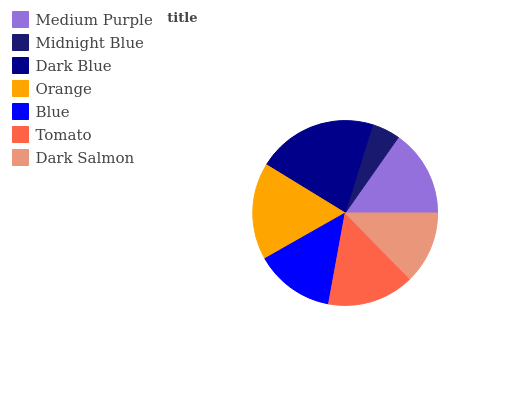Is Midnight Blue the minimum?
Answer yes or no. Yes. Is Dark Blue the maximum?
Answer yes or no. Yes. Is Dark Blue the minimum?
Answer yes or no. No. Is Midnight Blue the maximum?
Answer yes or no. No. Is Dark Blue greater than Midnight Blue?
Answer yes or no. Yes. Is Midnight Blue less than Dark Blue?
Answer yes or no. Yes. Is Midnight Blue greater than Dark Blue?
Answer yes or no. No. Is Dark Blue less than Midnight Blue?
Answer yes or no. No. Is Tomato the high median?
Answer yes or no. Yes. Is Tomato the low median?
Answer yes or no. Yes. Is Orange the high median?
Answer yes or no. No. Is Dark Salmon the low median?
Answer yes or no. No. 